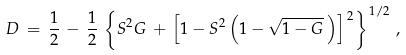Convert formula to latex. <formula><loc_0><loc_0><loc_500><loc_500>D \, = \, \frac { 1 } { 2 } \, - \, \frac { 1 } { 2 } \, \left \{ S ^ { 2 } G \, + \, \left [ 1 - S ^ { 2 } \left ( 1 - \sqrt { 1 - G } \, \right ) \right ] ^ { \, 2 } \right \} ^ { \, 1 / 2 } \, ,</formula> 